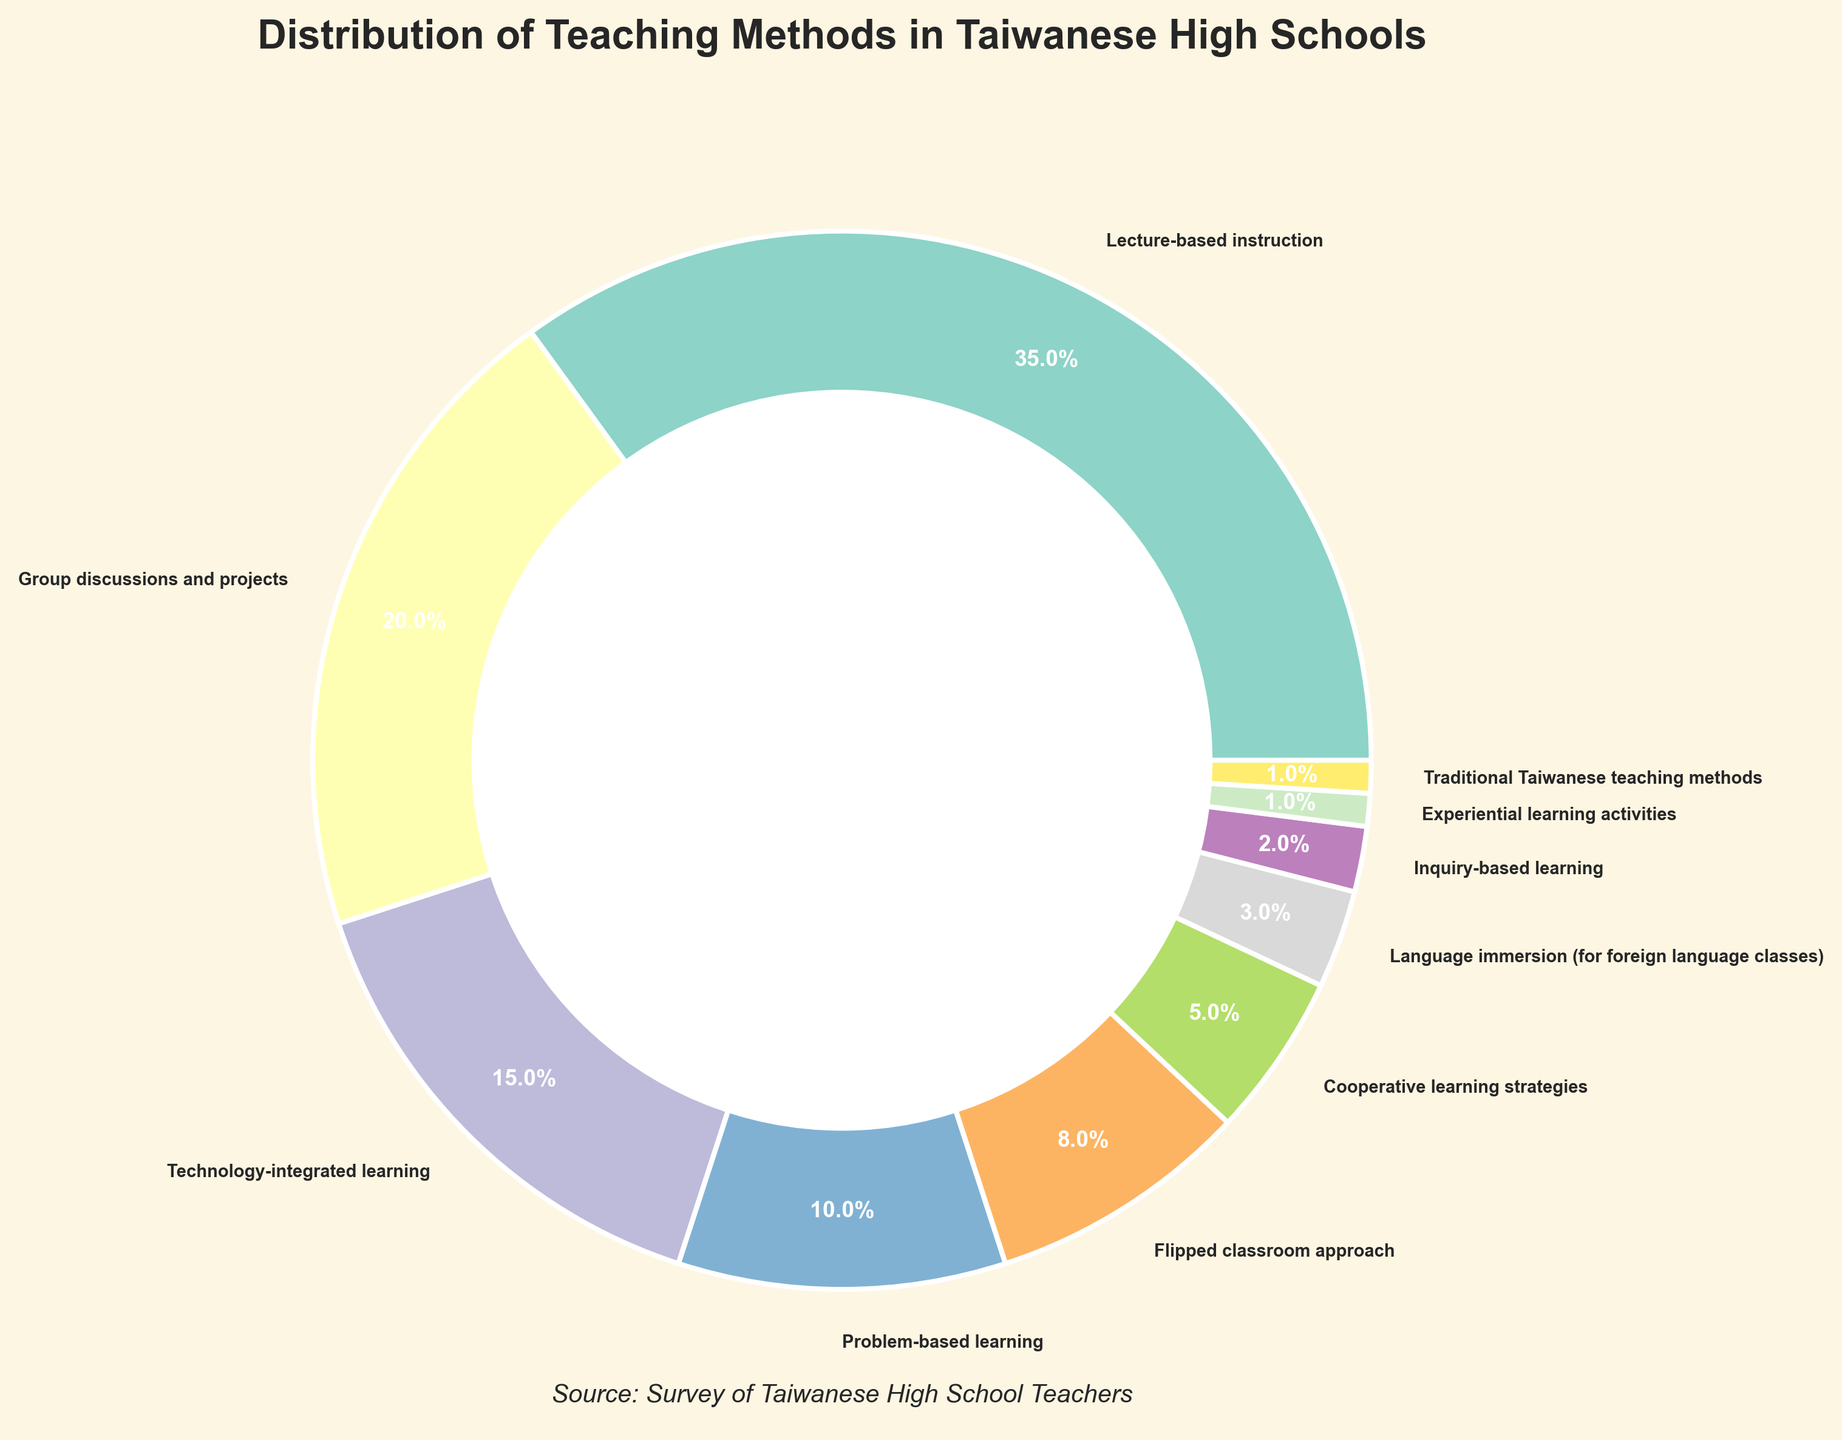What is the most commonly used teaching method in Taiwanese high schools? The most commonly used teaching method is the one with the highest percentage. According to the figure, lecture-based instruction is the largest segment in the pie chart, representing 35% of the total.
Answer: Lecture-based instruction Which teaching method has a higher percentage, group discussions and projects or technology-integrated learning? To determine which has a higher percentage, compare the two given values. Group discussions and projects have 20%, while technology-integrated learning has 15%. Since 20% > 15%, group discussions and projects have a higher percentage.
Answer: Group discussions and projects What is the combined percentage of problem-based learning and the flipped classroom approach? To find the combined percentage, add the values of problem-based learning and the flipped classroom approach. Problem-based learning is 10% and the flipped classroom approach is 8%. Thus, 10% + 8% = 18%.
Answer: 18% How does the use of traditional Taiwanese teaching methods compare to language immersion? Compare the percentage values for both teaching methods. Traditional Taiwanese teaching methods and language immersion both form small sections of the pie chart, but traditional Taiwanese teaching methods have 1%, whereas language immersion has 3%. Since 3% > 1%, language immersion is used more.
Answer: Language immersion What percentage of the total do the least used teaching methods (Inquiry-based learning, Experiential learning activities, Traditional Taiwanese teaching methods) together constitute? Add the percentages of the three least used teaching methods in the figure. Inquiry-based learning is 2%, experiential learning activities is 1%, and traditional Taiwanese teaching methods is 1%. So, 2% + 1% + 1% = 4%.
Answer: 4% Which visual attribute helps distinguish the sections of the pie chart? The sections of the pie chart are distinguished by different colors and labels with their respective percentages. These colors help visually differentiate each teaching method's percentage contribution.
Answer: Colors and labels What is the percentage difference between the use of cooperative learning strategies and technology-integrated learning? Subtract the percentage of cooperative learning strategies from technology-integrated learning. Cooperative learning strategies is 5% and technology-integrated learning is 15%, so the difference is 15% - 5% = 10%.
Answer: 10% How much more common is lecture-based instruction compared to flipped classroom approach? Subtract the percentage of the flipped classroom approach from lecture-based instruction. Lecture-based instruction is 35% and flipped classroom approach is 8%, so the difference is 35% - 8% = 27%.
Answer: 27% Which teaching methods occupy less than 5% of the total distribution? Look for segments in the pie chart with percentages less than 5%. According to the chart, cooperative learning strategies (5%), language immersion (3%), inquiry-based learning (2%), experiential learning activities (1%), and traditional Taiwanese teaching methods (1%) all occupy less than 5% each.
Answer: Cooperative learning strategies, language immersion, inquiry-based learning, experiential learning activities, traditional Taiwanese teaching methods What is the sum of the percentages of teaching methods that use technology (technology-integrated learning, flipped classroom approach) and problem-based learning? Add the percentages of technology-integrated learning, flipped classroom approach, and problem-based learning. Technology-integrated learning is 15%, flipped classroom approach is 8%, and problem-based learning is 10%. Thus, 15% + 8% + 10% = 33%.
Answer: 33% 